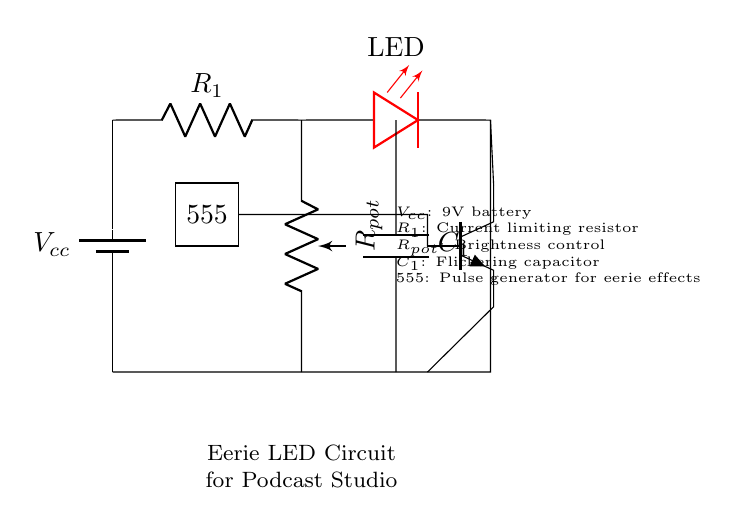What is the power supply voltage? The power supply voltage, labeled as Vcc, is indicated to be 9V in the circuit diagram.
Answer: 9 volts What component controls the brightness of the LED? The brightness of the LED is controlled by a potentiometer, labeled as Rpot, which allows for adjustable resistance in the circuit.
Answer: Potentiometer What is the role of the 555 timer in this circuit? The 555 timer generates pulses that create eerie lighting effects by controlling the behavior of the transistor and thereby the LED.
Answer: Pulse generator How many main components are in the circuit? The circuit consists of five main components: a battery, a resistor, an LED, a potentiometer, and a capacitor, along with a transistor and a 555 timer, making it seven in total.
Answer: Seven What type of capacitor is used? The circuit uses a capacitor for flickering effects, labeled as C1, which contributes to creating a more dynamic lighting appearance.
Answer: Flickering capacitor What is the purpose of the NPN transistor? The NPN transistor acts as a switch in the circuit, modulating the current flow to the LED based on the pulse input from the 555 timer.
Answer: Switching What is the effect of the flickering capacitor on the LED? The flickering capacitor causes the LED to periodically turn on and off, producing an eerie effect suitable for a podcast recording environment.
Answer: Eerie flickering effect 